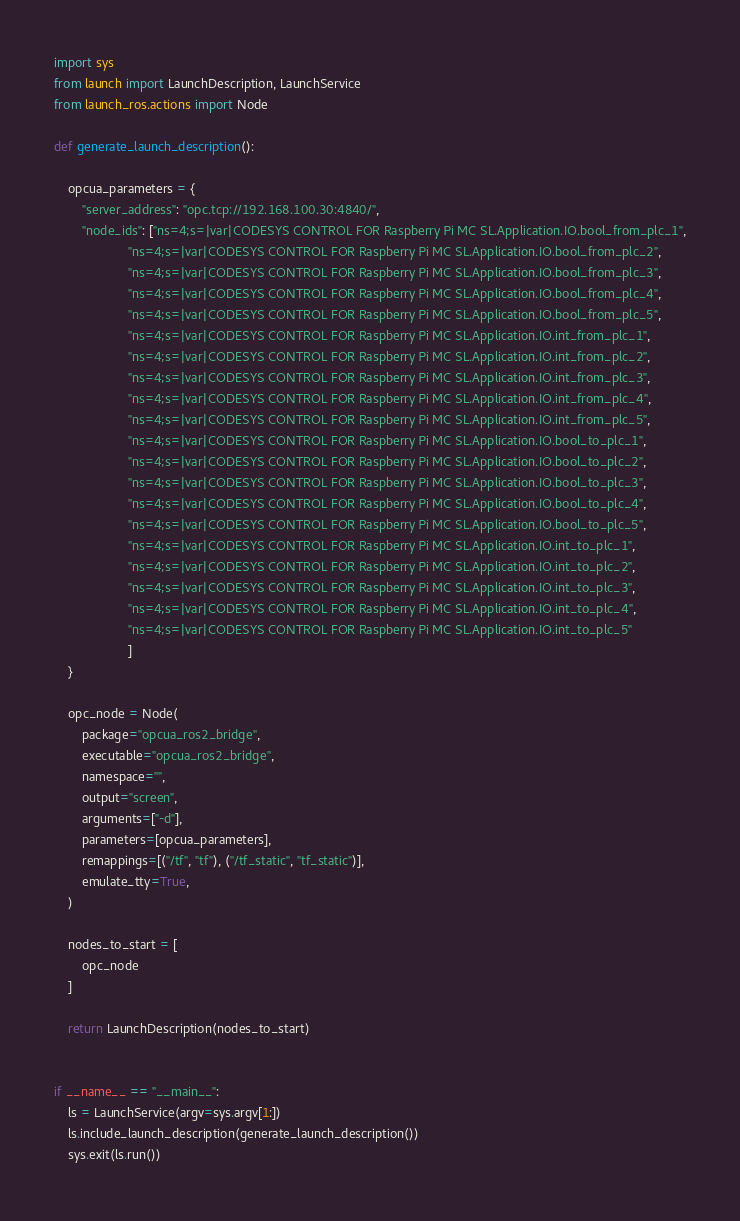<code> <loc_0><loc_0><loc_500><loc_500><_Python_>import sys
from launch import LaunchDescription, LaunchService
from launch_ros.actions import Node

def generate_launch_description():

    opcua_parameters = {
        "server_address": "opc.tcp://192.168.100.30:4840/",
        "node_ids": ["ns=4;s=|var|CODESYS CONTROL FOR Raspberry Pi MC SL.Application.IO.bool_from_plc_1",
                     "ns=4;s=|var|CODESYS CONTROL FOR Raspberry Pi MC SL.Application.IO.bool_from_plc_2", 
                     "ns=4;s=|var|CODESYS CONTROL FOR Raspberry Pi MC SL.Application.IO.bool_from_plc_3", 
                     "ns=4;s=|var|CODESYS CONTROL FOR Raspberry Pi MC SL.Application.IO.bool_from_plc_4", 
                     "ns=4;s=|var|CODESYS CONTROL FOR Raspberry Pi MC SL.Application.IO.bool_from_plc_5", 
                     "ns=4;s=|var|CODESYS CONTROL FOR Raspberry Pi MC SL.Application.IO.int_from_plc_1",
                     "ns=4;s=|var|CODESYS CONTROL FOR Raspberry Pi MC SL.Application.IO.int_from_plc_2", 
                     "ns=4;s=|var|CODESYS CONTROL FOR Raspberry Pi MC SL.Application.IO.int_from_plc_3", 
                     "ns=4;s=|var|CODESYS CONTROL FOR Raspberry Pi MC SL.Application.IO.int_from_plc_4", 
                     "ns=4;s=|var|CODESYS CONTROL FOR Raspberry Pi MC SL.Application.IO.int_from_plc_5",
                     "ns=4;s=|var|CODESYS CONTROL FOR Raspberry Pi MC SL.Application.IO.bool_to_plc_1",
                     "ns=4;s=|var|CODESYS CONTROL FOR Raspberry Pi MC SL.Application.IO.bool_to_plc_2", 
                     "ns=4;s=|var|CODESYS CONTROL FOR Raspberry Pi MC SL.Application.IO.bool_to_plc_3", 
                     "ns=4;s=|var|CODESYS CONTROL FOR Raspberry Pi MC SL.Application.IO.bool_to_plc_4", 
                     "ns=4;s=|var|CODESYS CONTROL FOR Raspberry Pi MC SL.Application.IO.bool_to_plc_5", 
                     "ns=4;s=|var|CODESYS CONTROL FOR Raspberry Pi MC SL.Application.IO.int_to_plc_1",
                     "ns=4;s=|var|CODESYS CONTROL FOR Raspberry Pi MC SL.Application.IO.int_to_plc_2", 
                     "ns=4;s=|var|CODESYS CONTROL FOR Raspberry Pi MC SL.Application.IO.int_to_plc_3", 
                     "ns=4;s=|var|CODESYS CONTROL FOR Raspberry Pi MC SL.Application.IO.int_to_plc_4", 
                     "ns=4;s=|var|CODESYS CONTROL FOR Raspberry Pi MC SL.Application.IO.int_to_plc_5"
                     ]
    }

    opc_node = Node(
        package="opcua_ros2_bridge",
        executable="opcua_ros2_bridge",
        namespace="",
        output="screen",
        arguments=["-d"],
        parameters=[opcua_parameters],
        remappings=[("/tf", "tf"), ("/tf_static", "tf_static")],
        emulate_tty=True,
    )

    nodes_to_start = [
        opc_node
    ]
    
    return LaunchDescription(nodes_to_start)


if __name__ == "__main__":
    ls = LaunchService(argv=sys.argv[1:])
    ls.include_launch_description(generate_launch_description())
    sys.exit(ls.run())
</code> 